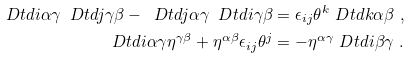<formula> <loc_0><loc_0><loc_500><loc_500>\ D t d { i } { \alpha } { \gamma } \ D t d { j } { \gamma } { \beta } - \ D t d { j } { \alpha } { \gamma } \ D t d { i } { \gamma } { \beta } & = \epsilon _ { i j } \theta ^ { k } \ D t d { k } { \alpha } { \beta } \ , \\ \ D t d { i } { \alpha } { \gamma } \eta ^ { \gamma \beta } + \eta ^ { \alpha \beta } \epsilon _ { i j } \theta ^ { j } & = - \eta ^ { \alpha \gamma } \ D t d { i } { \beta } { \gamma } \ .</formula> 